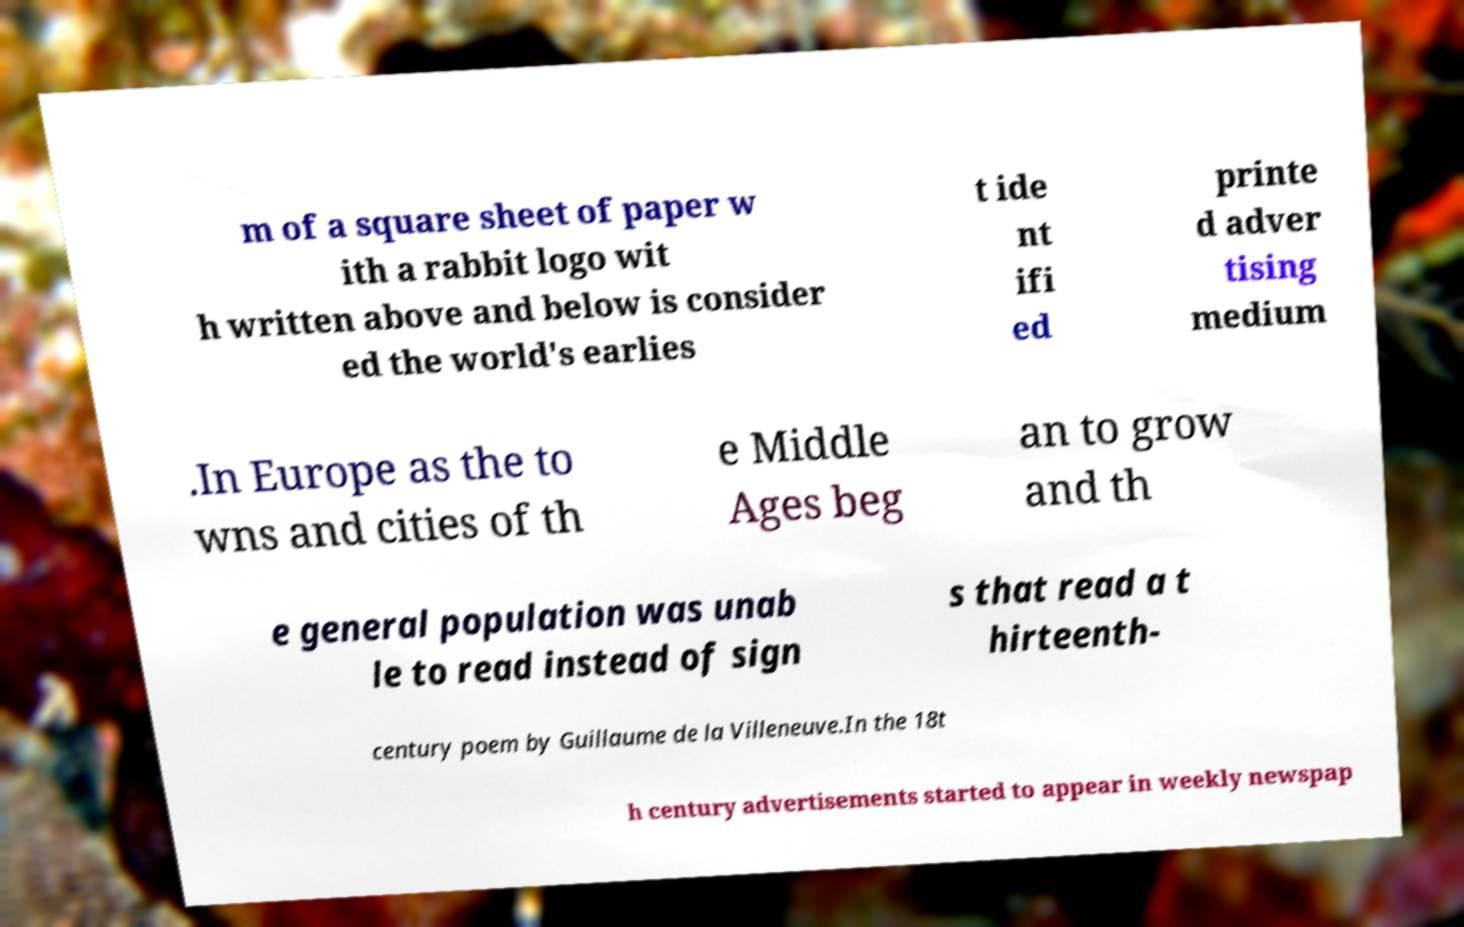Please read and relay the text visible in this image. What does it say? m of a square sheet of paper w ith a rabbit logo wit h written above and below is consider ed the world's earlies t ide nt ifi ed printe d adver tising medium .In Europe as the to wns and cities of th e Middle Ages beg an to grow and th e general population was unab le to read instead of sign s that read a t hirteenth- century poem by Guillaume de la Villeneuve.In the 18t h century advertisements started to appear in weekly newspap 